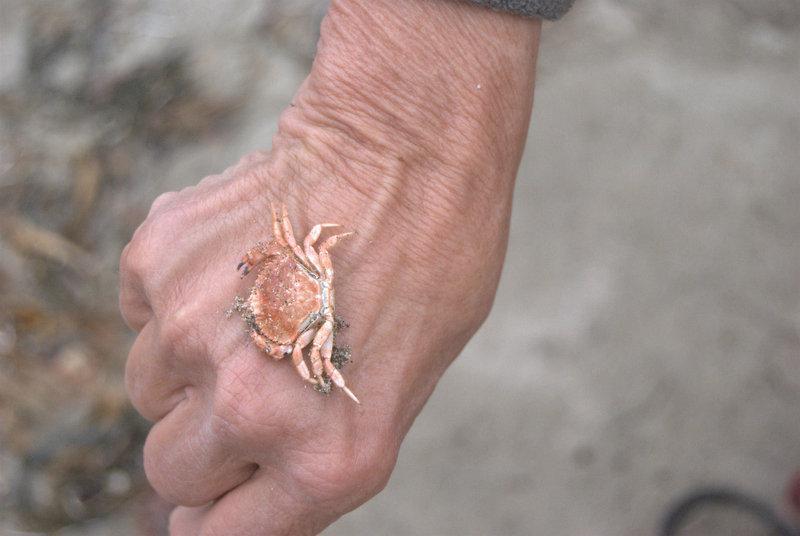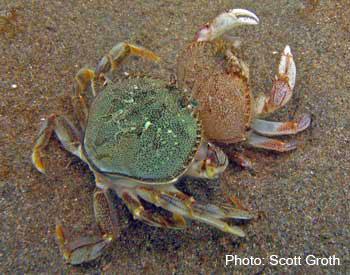The first image is the image on the left, the second image is the image on the right. For the images shown, is this caption "The left image contains a human touching a crab." true? Answer yes or no. Yes. The first image is the image on the left, the second image is the image on the right. Considering the images on both sides, is "In at least one image there is a hand touching a crab." valid? Answer yes or no. Yes. 